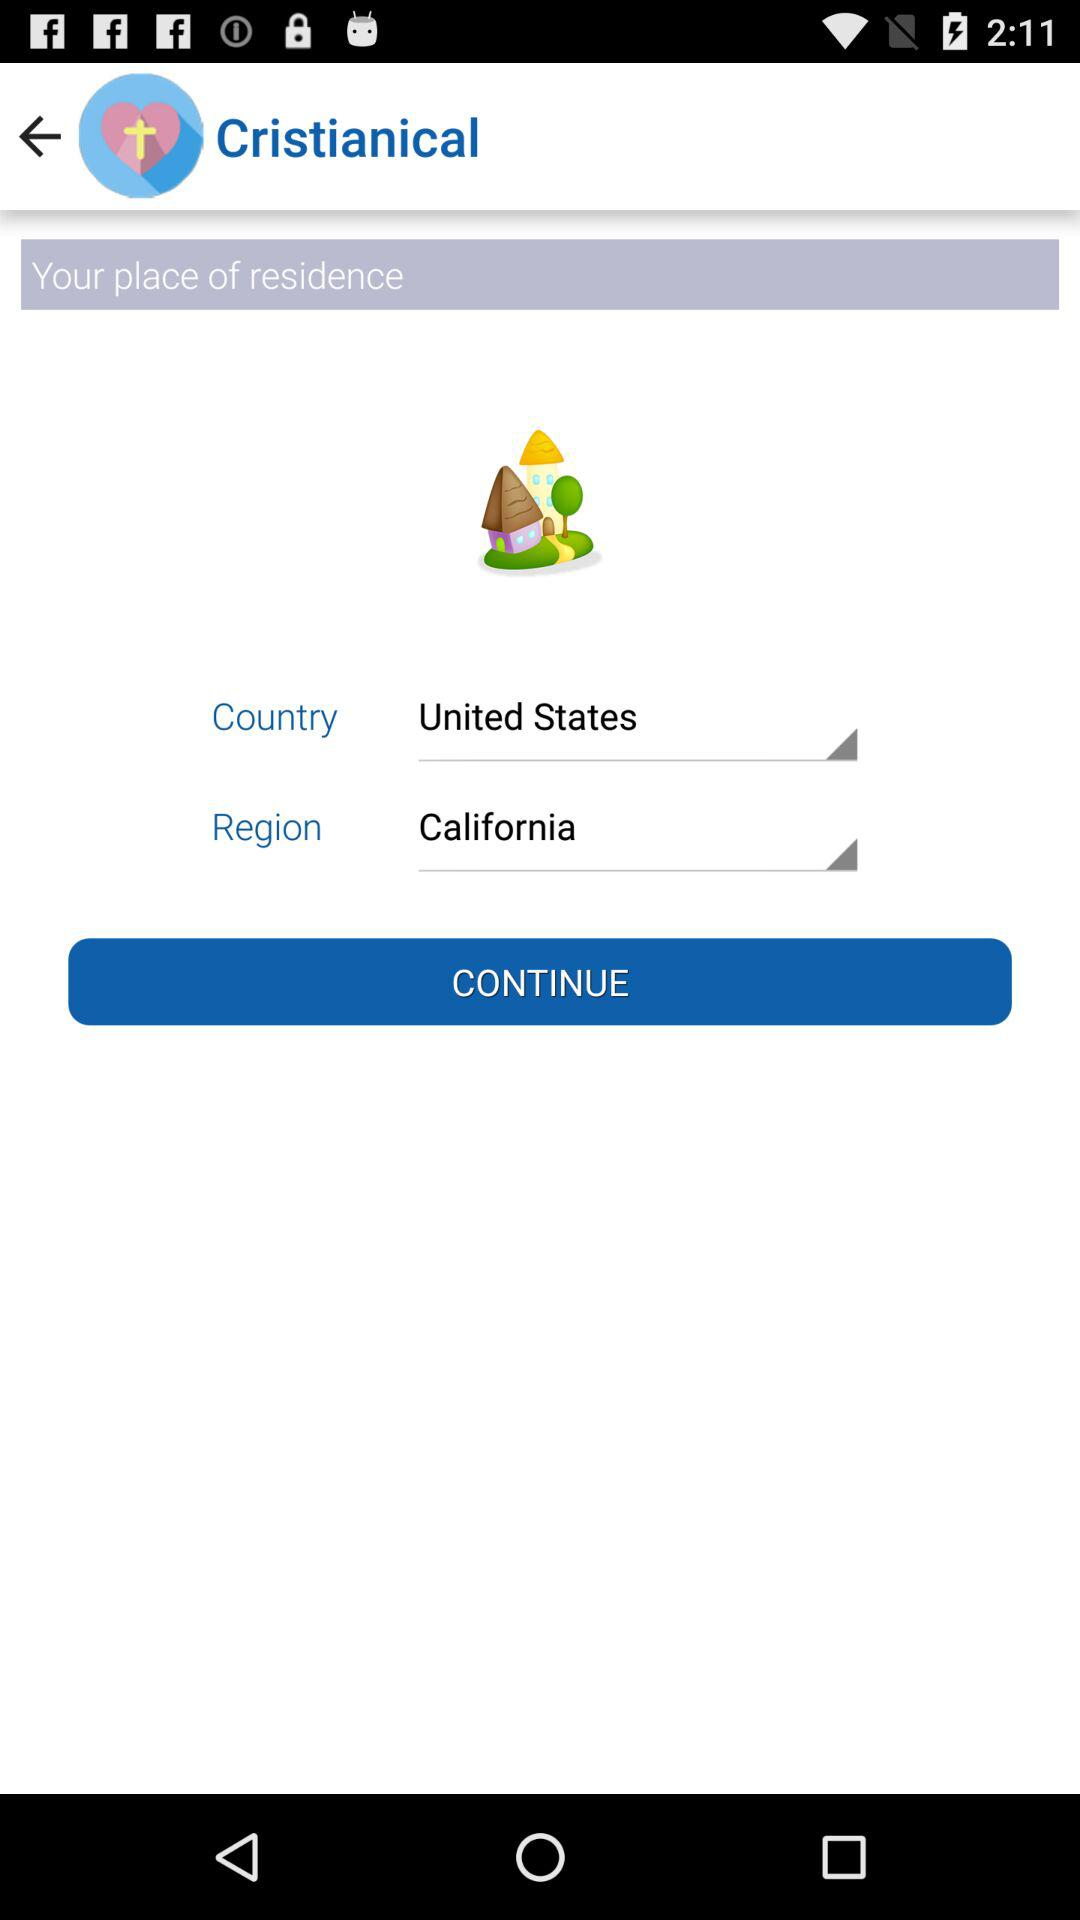What is the name of the application? The name of the application is "Cristianical". 